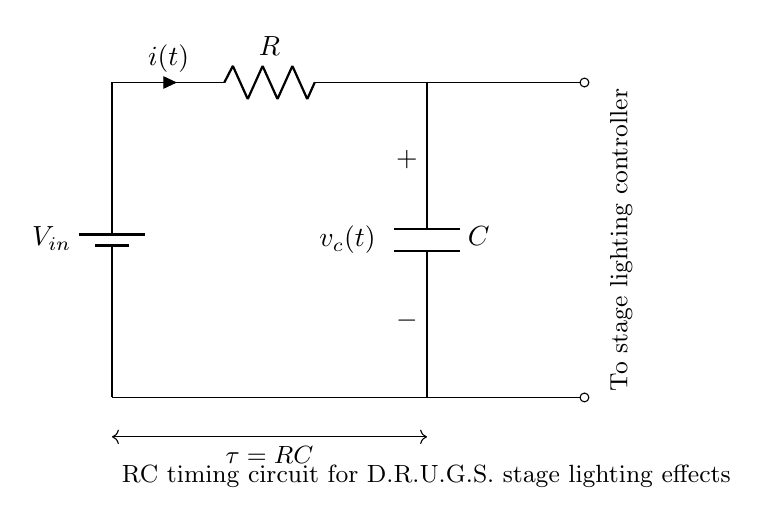What type of circuit is depicted? This circuit is an RC timing circuit, which consists of a resistor and a capacitor. The purpose of this type of circuit is to create a time delay in the system, which is useful in applications like stage lighting effects.
Answer: RC timing circuit What does \( V_{in} \) represent? \( V_{in} \) symbolizes the input voltage supplied to the circuit. In this case, it serves as the voltage source for the timing effect of the RC circuit in relation to the stage lighting.
Answer: Input voltage What is the formula for the time constant \( \tau \)? The time constant \( \tau \) is calculated as the product of resistance \( R \) and capacitance \( C \). This time constant is crucial as it determines how quickly the circuit responds to changes in voltage, affecting the lighting effects.
Answer: \( \tau = RC \) Where do the outputs of the circuit connect? The outputs connect to a stage lighting controller. This indicates that the circuit is designed to interface directly with the lighting system to control effects based on the timing provided by the RC circuit.
Answer: Stage lighting controller What is the current direction in the circuit? The current \( i(t) \) flows from the battery, through the resistor, and then charges the capacitor. The direction is indicated by the arrow next to \( i(t) \), showing conventional current flow.
Answer: From battery to capacitor What happens when \( C \) is increased? Increasing \( C \) will lead to a longer time constant \( \tau \), which means the circuit will take longer to charge to the input voltage, thus delaying the lighting effect. This change impacts how quickly the lights will respond.
Answer: Longer delay How does the resistor affect the circuit's timing? The resistor \( R \) affects the charging rate of the capacitor. A larger resistor slows down the current flow, increasing the time it takes for the capacitor to charge to the input voltage, which influences the timing of the stage lighting effects.
Answer: Slows down timing 